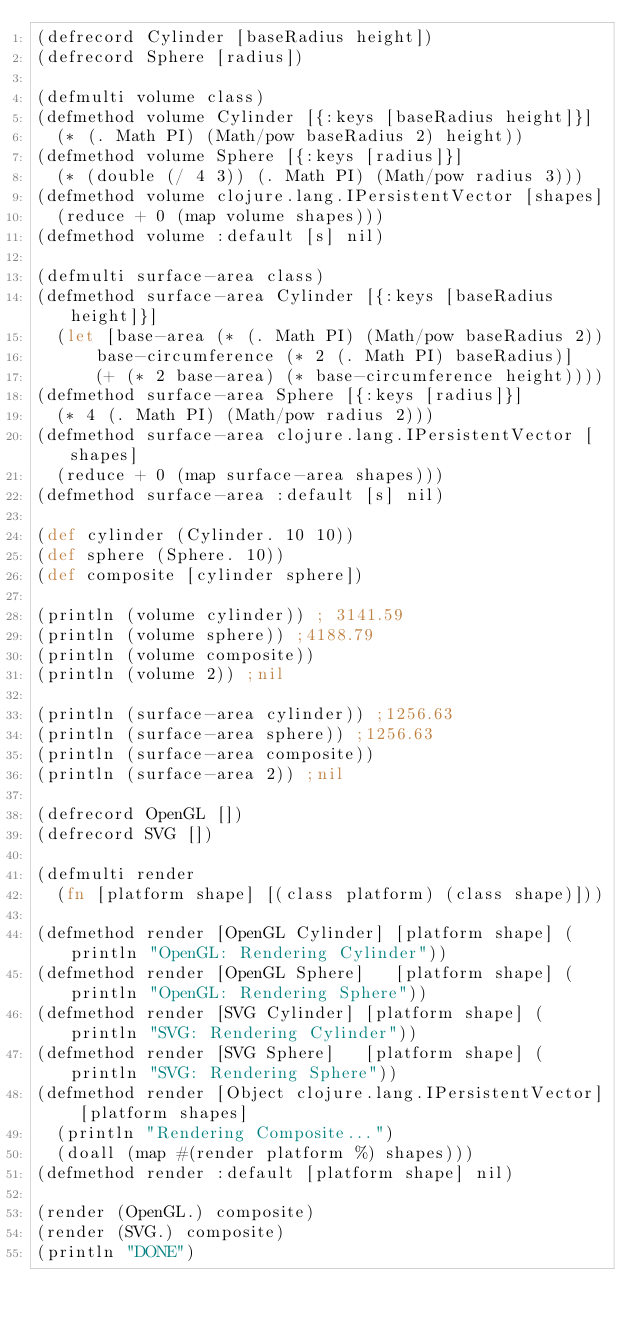<code> <loc_0><loc_0><loc_500><loc_500><_Clojure_>(defrecord Cylinder [baseRadius height])
(defrecord Sphere [radius])

(defmulti volume class)
(defmethod volume Cylinder [{:keys [baseRadius height]}]
  (* (. Math PI) (Math/pow baseRadius 2) height))
(defmethod volume Sphere [{:keys [radius]}] 
  (* (double (/ 4 3)) (. Math PI) (Math/pow radius 3)))
(defmethod volume clojure.lang.IPersistentVector [shapes]
  (reduce + 0 (map volume shapes)))
(defmethod volume :default [s] nil)

(defmulti surface-area class)
(defmethod surface-area Cylinder [{:keys [baseRadius height]}]
	(let [base-area (* (. Math PI) (Math/pow baseRadius 2))
	    base-circumference (* 2 (. Math PI) baseRadius)]
	    (+ (* 2 base-area) (* base-circumference height))))
(defmethod surface-area Sphere [{:keys [radius]}] 
  (* 4 (. Math PI) (Math/pow radius 2)))
(defmethod surface-area clojure.lang.IPersistentVector [shapes]
  (reduce + 0 (map surface-area shapes)))
(defmethod surface-area :default [s] nil)

(def cylinder (Cylinder. 10 10))
(def sphere (Sphere. 10))
(def composite [cylinder sphere])

(println (volume cylinder)) ; 3141.59
(println (volume sphere)) ;4188.79
(println (volume composite)) 
(println (volume 2)) ;nil

(println (surface-area cylinder)) ;1256.63
(println (surface-area sphere)) ;1256.63
(println (surface-area composite)) 
(println (surface-area 2)) ;nil

(defrecord OpenGL [])
(defrecord SVG [])

(defmulti render 
  (fn [platform shape] [(class platform) (class shape)]))
  
(defmethod render [OpenGL Cylinder] [platform shape] (println "OpenGL: Rendering Cylinder"))
(defmethod render [OpenGL Sphere]   [platform shape] (println "OpenGL: Rendering Sphere"))
(defmethod render [SVG Cylinder] [platform shape] (println "SVG: Rendering Cylinder"))
(defmethod render [SVG Sphere]   [platform shape] (println "SVG: Rendering Sphere"))
(defmethod render [Object clojure.lang.IPersistentVector] [platform shapes] 
  (println "Rendering Composite...")
  (doall (map #(render platform %) shapes)))
(defmethod render :default [platform shape] nil)

(render (OpenGL.) composite)
(render (SVG.) composite)
(println "DONE")
</code> 